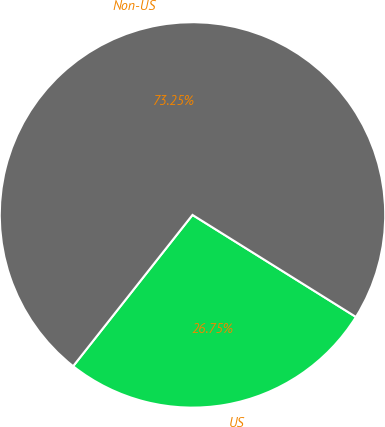<chart> <loc_0><loc_0><loc_500><loc_500><pie_chart><fcel>US<fcel>Non-US<nl><fcel>26.75%<fcel>73.25%<nl></chart> 